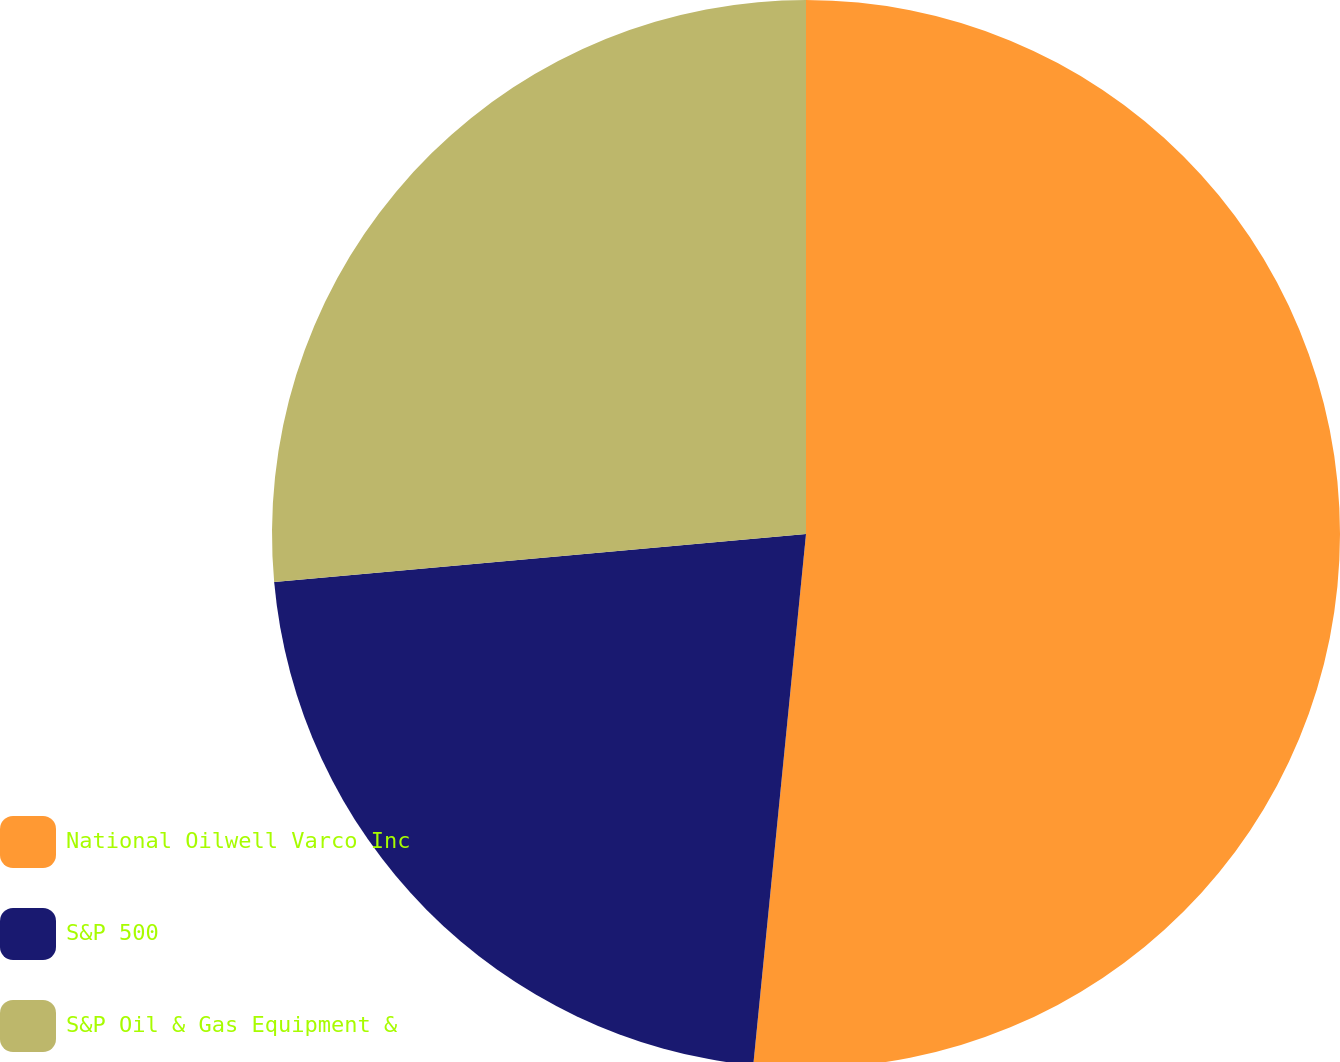<chart> <loc_0><loc_0><loc_500><loc_500><pie_chart><fcel>National Oilwell Varco Inc<fcel>S&P 500<fcel>S&P Oil & Gas Equipment &<nl><fcel>51.57%<fcel>21.99%<fcel>26.43%<nl></chart> 